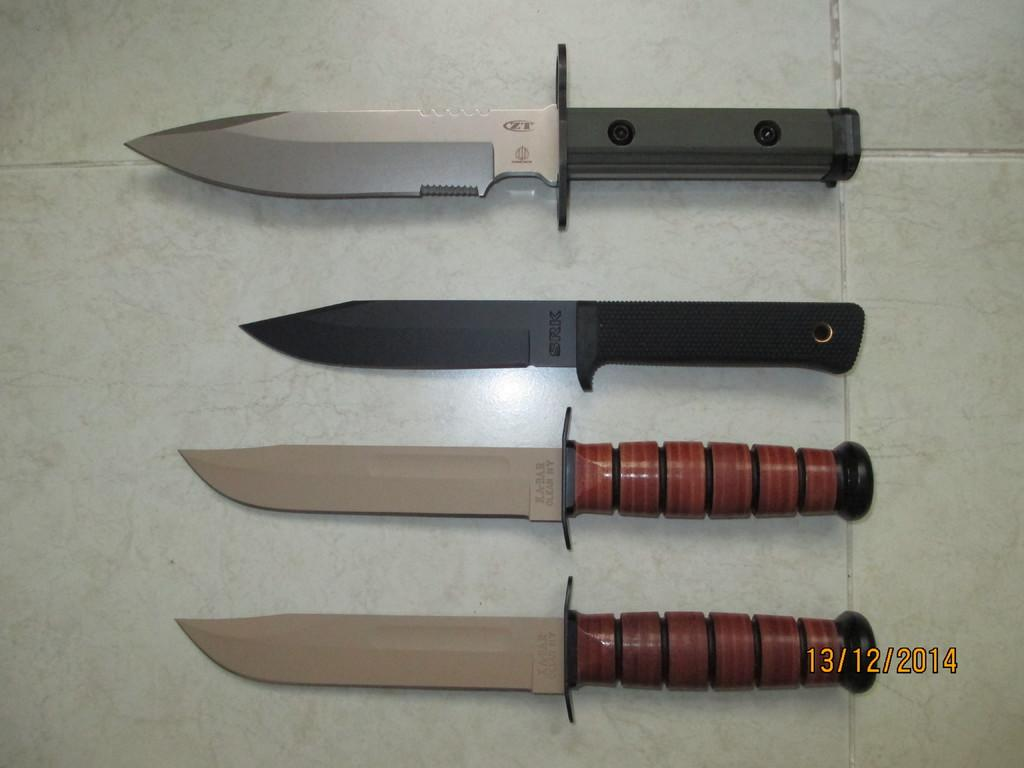What type of flooring is visible in the image? The floor in the image has white tiles. What objects can be seen on the floor? There are four knives with different types in the image. What type of agreement is being made in the image? There is no indication of an agreement being made in the image, as it only features a floor with white tiles and four knives with different types. 